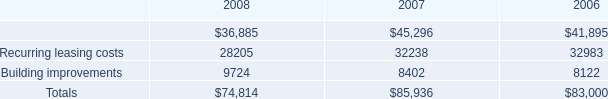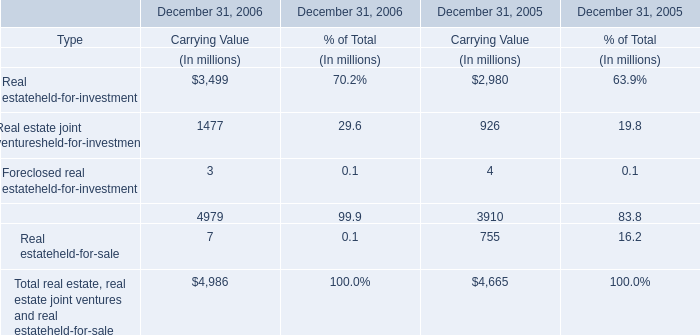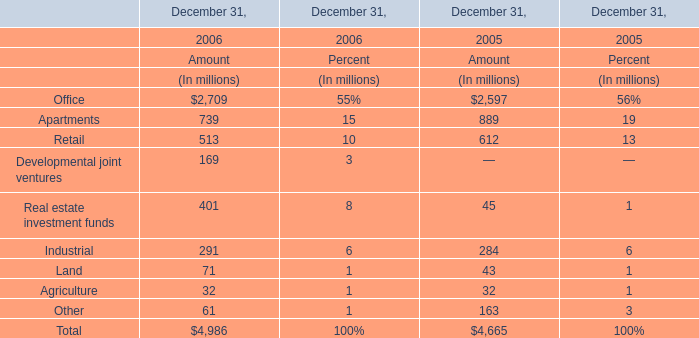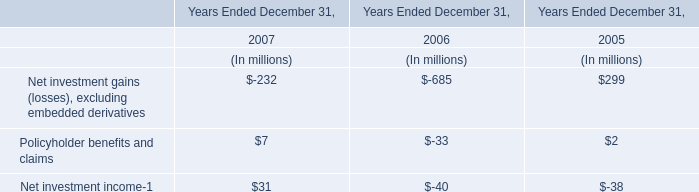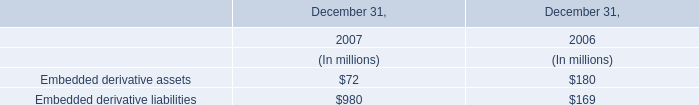What is the proportion of Retail to the total in 2005 ? (in %) 
Computations: (612 / 4665)
Answer: 0.13119. 